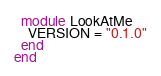<code> <loc_0><loc_0><loc_500><loc_500><_Ruby_>  module LookAtMe
    VERSION = "0.1.0"
  end
end
</code> 